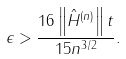Convert formula to latex. <formula><loc_0><loc_0><loc_500><loc_500>\epsilon > \frac { 1 6 \left \| \hat { H } ^ { ( n ) } \right \| t } { 1 5 n ^ { 3 / 2 } } .</formula> 